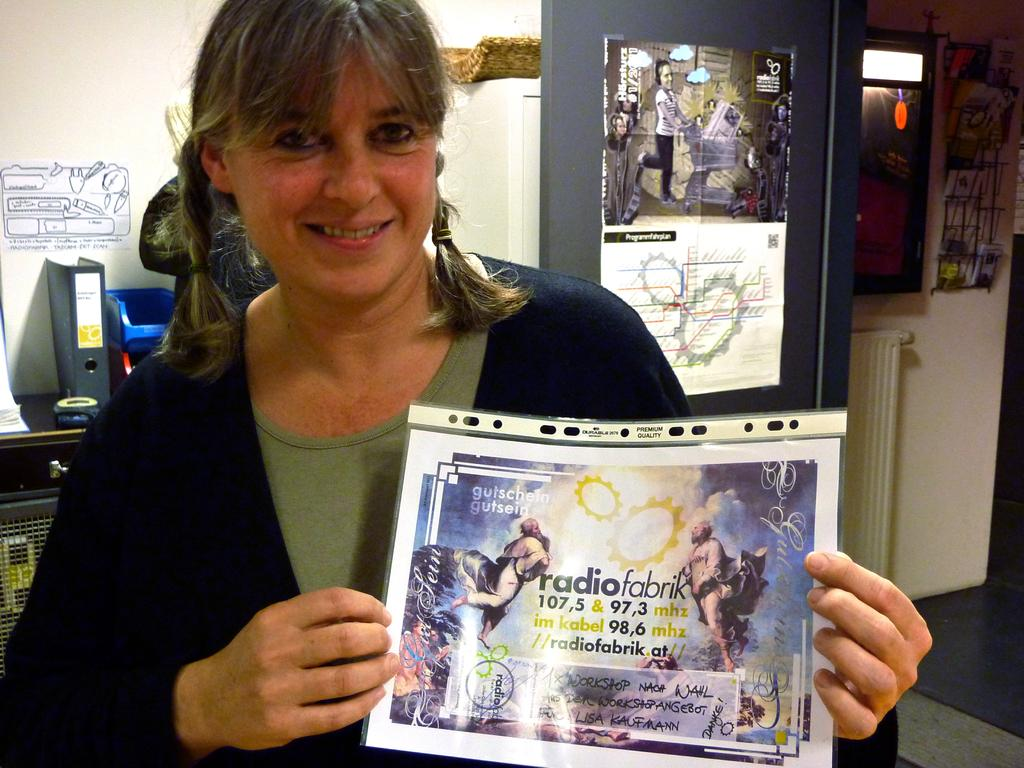<image>
Share a concise interpretation of the image provided. A woman holds a paper advertisement for radiofabrik. 